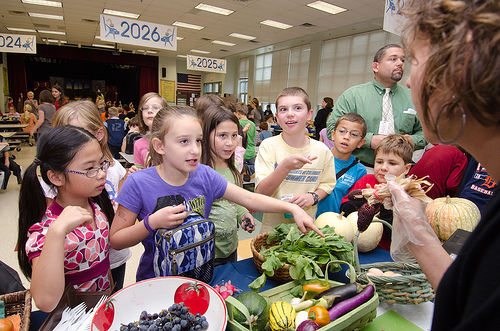<image>
Is there a girl on the girl? No. The girl is not positioned on the girl. They may be near each other, but the girl is not supported by or resting on top of the girl. 